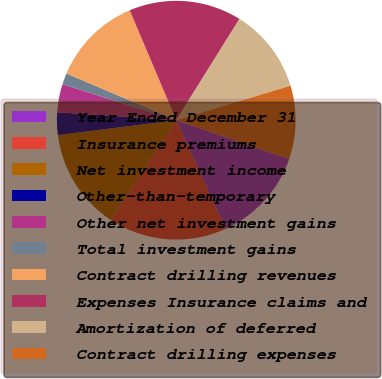Convert chart. <chart><loc_0><loc_0><loc_500><loc_500><pie_chart><fcel>Year Ended December 31<fcel>Insurance premiums<fcel>Net investment income<fcel>Other-than-temporary<fcel>Other net investment gains<fcel>Total investment gains<fcel>Contract drilling revenues<fcel>Expenses Insurance claims and<fcel>Amortization of deferred<fcel>Contract drilling expenses<nl><fcel>12.98%<fcel>16.03%<fcel>13.74%<fcel>3.05%<fcel>3.82%<fcel>1.53%<fcel>12.21%<fcel>15.27%<fcel>11.45%<fcel>9.92%<nl></chart> 